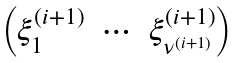<formula> <loc_0><loc_0><loc_500><loc_500>\begin{pmatrix} \xi _ { 1 } ^ { ( i + 1 ) } & \cdots & \xi _ { \nu ^ { ( i + 1 ) } } ^ { ( i + 1 ) } \end{pmatrix}</formula> 